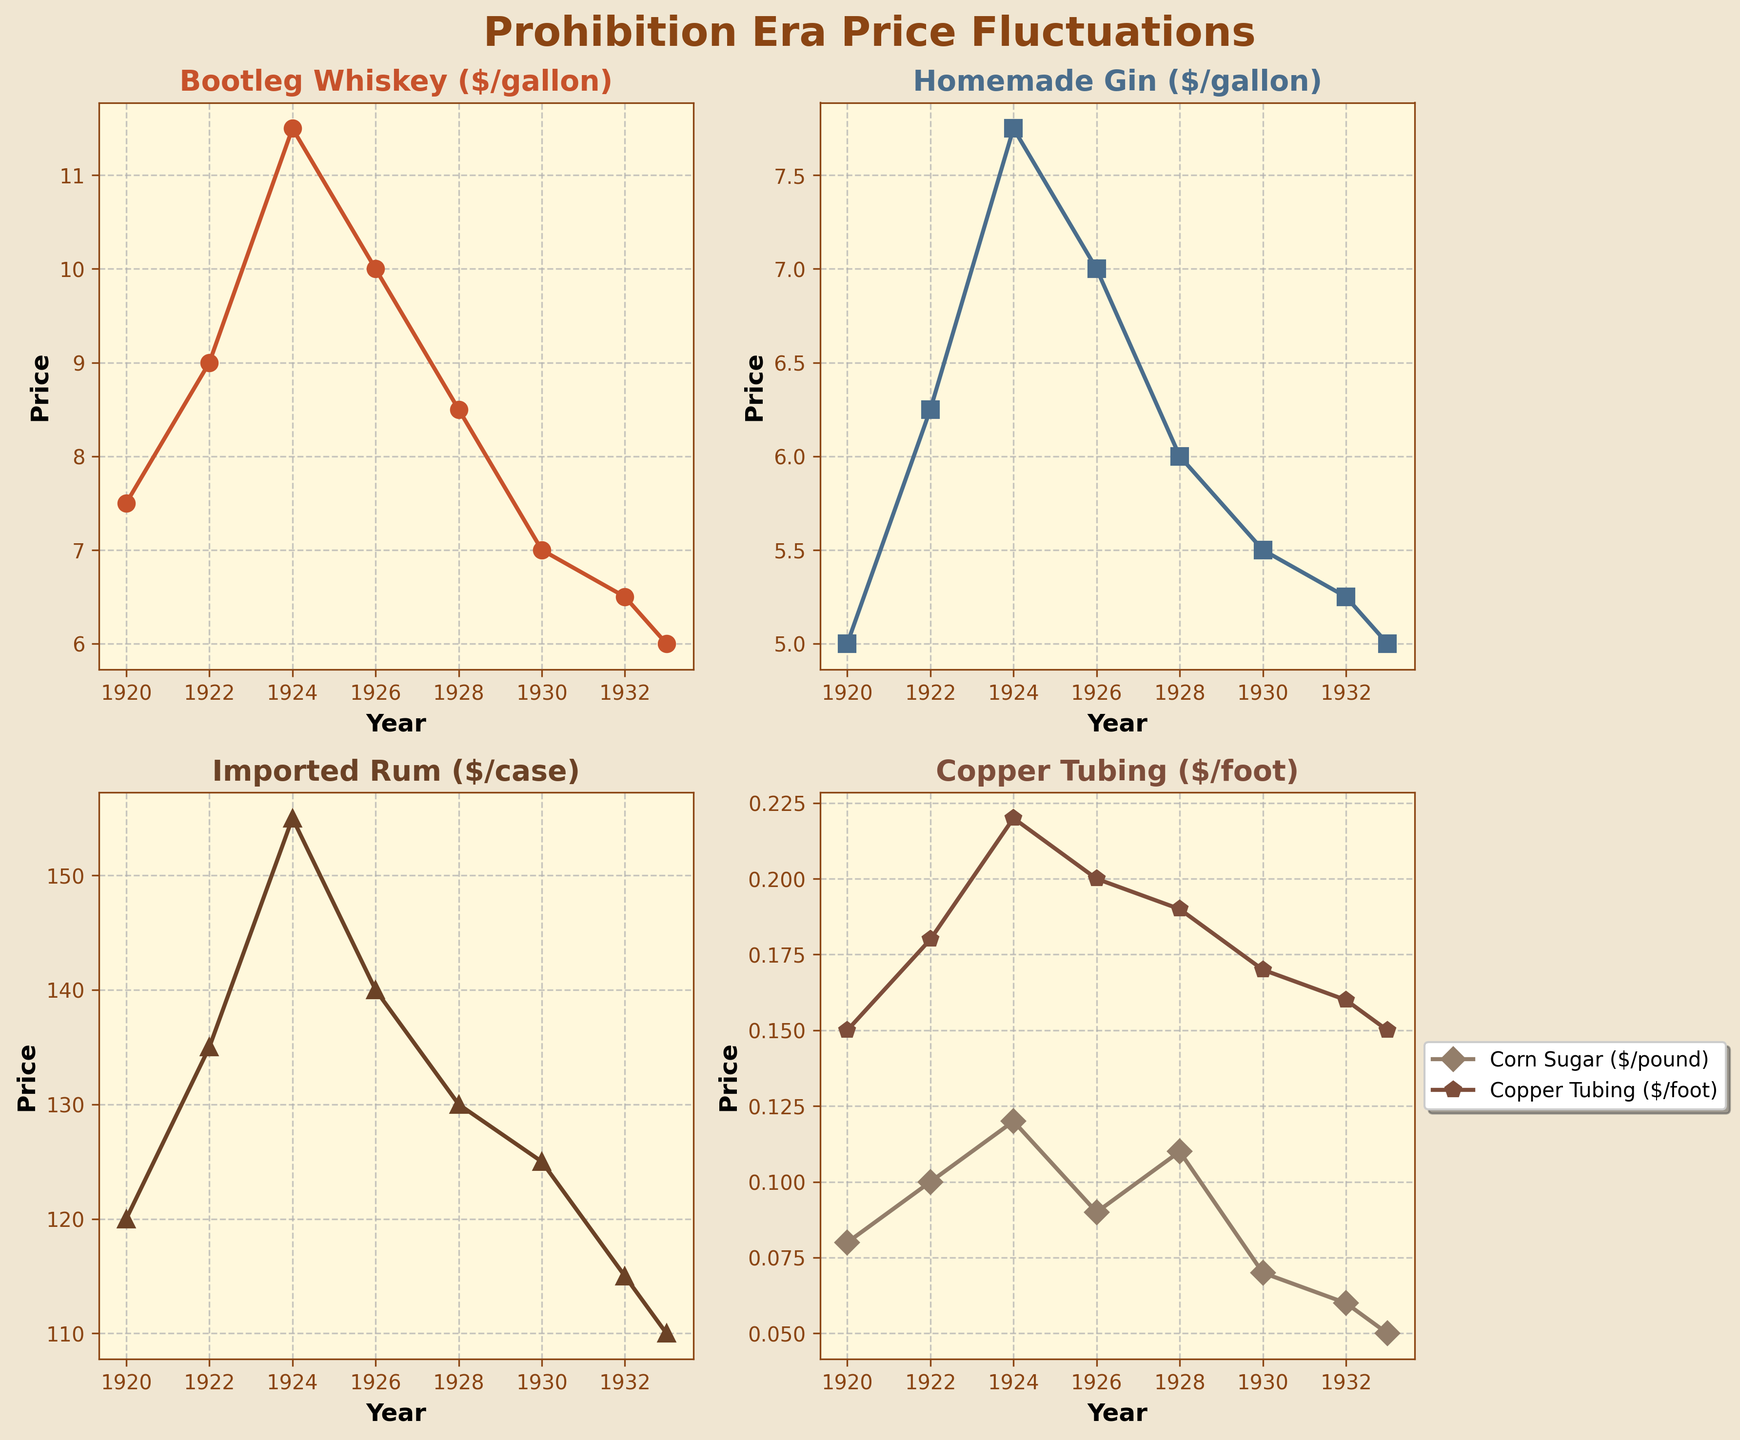What is the title of the figure? The title is typically placed at the top of the chart. The first line of the figure clearly states, "Prohibition Era Price Fluctuations".
Answer: Prohibition Era Price Fluctuations What years are covered in the data? The x-axis of each subplot lists the years. These years are visible from 1920 to 1933.
Answer: 1920 to 1933 Which commodity had the highest price in 1924? The 1924 data point on each subplot reveals the prices. Bootleg Whiskey costs $11.50, Homemade Gin is $7.75, Imported Rum per case is $155, Corn Sugar per pound is $0.12, and Copper Tubing per foot is $0.22. Imported Rum has the highest price at $155.
Answer: Imported Rum How does the price of Homemade Gin change from 1920 to 1933? Observe the line for Homemade Gin from 1920 to 1933. It starts at $5 in 1920, increases to $6.25 in 1922, peaks at $7.75 in 1924, and fluctuates down to $5 again in 1933.
Answer: It fluctuates but ultimately returns to $5 Which year shows the largest decrease in the price of Bootleg Whiskey from the previous year? Comparing each year's price for Bootleg Whiskey, from 1926 to 1928, the price drops from $10 to $8.50, a decrease of $1.50, the largest observed in the series.
Answer: Between 1926 and 1928 Compare the trends for Corn Sugar and Copper Tubing. Which one shows a more consistent trend? Look at the line plots for Corn Sugar and Copper Tubing. Corn Sugar prices are more variable, rising and falling, while Copper Tubing exhibits slight fluctuations but remains more stable.
Answer: Copper Tubing What is the price difference between Bootleg Whiskey and Homemade Gin in 1930? Check the 1930 data points for both commodities: Bootleg Whiskey is $7, and Homemade Gin is $5.50, making the price difference $7 - $5.50 = $1.50.
Answer: $1.50 In which year did Imported Rum see the least price? By observing each data point of Imported Rum, the least price is in 1933, which is $110.
Answer: 1933 Which commodity shows a steady decline in price throughout the years? Check the trends for all commodities. Bootleg Whiskey shows a consistent decline from 1924 to 1933.
Answer: Bootleg Whiskey How does the plot's background color relate to the Prohibition Era theme? Each subplot has a background face color of a beige shade. Beige may invoke a sense of antiquity that fits the historical Prohibition Era.
Answer: It evokes an antiquated feel 